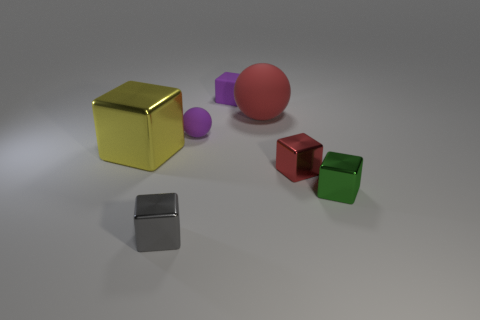Aside from geometry, can we discuss the lighting and shadows in the scene? Absolutely, the image has subtle lighting with soft shadows cast by each object. The direction of the shadows suggests a single light source vaguely to the top right of the frame, creating a soft ambiance and gentle contrasts. 